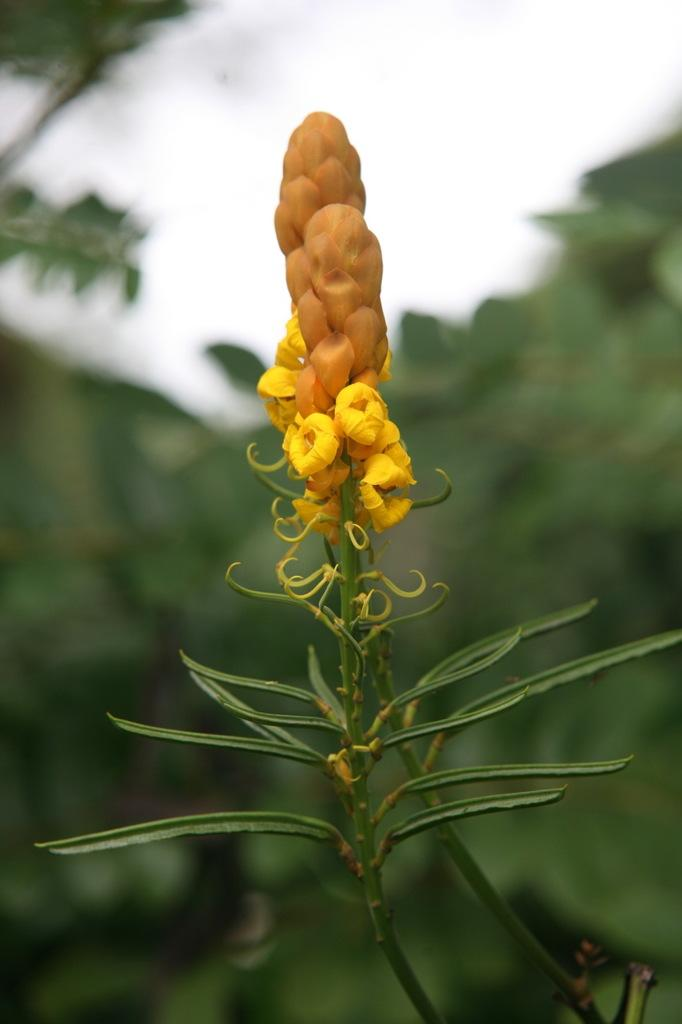What is located in the foreground of the image? There is a plant in the foreground of the image. What can be seen in the background of the image? There is greenery and the sky visible in the background of the image. How many holes can be seen in the sheet in the image? There is no sheet present in the image, so it is not possible to determine the number of holes. 